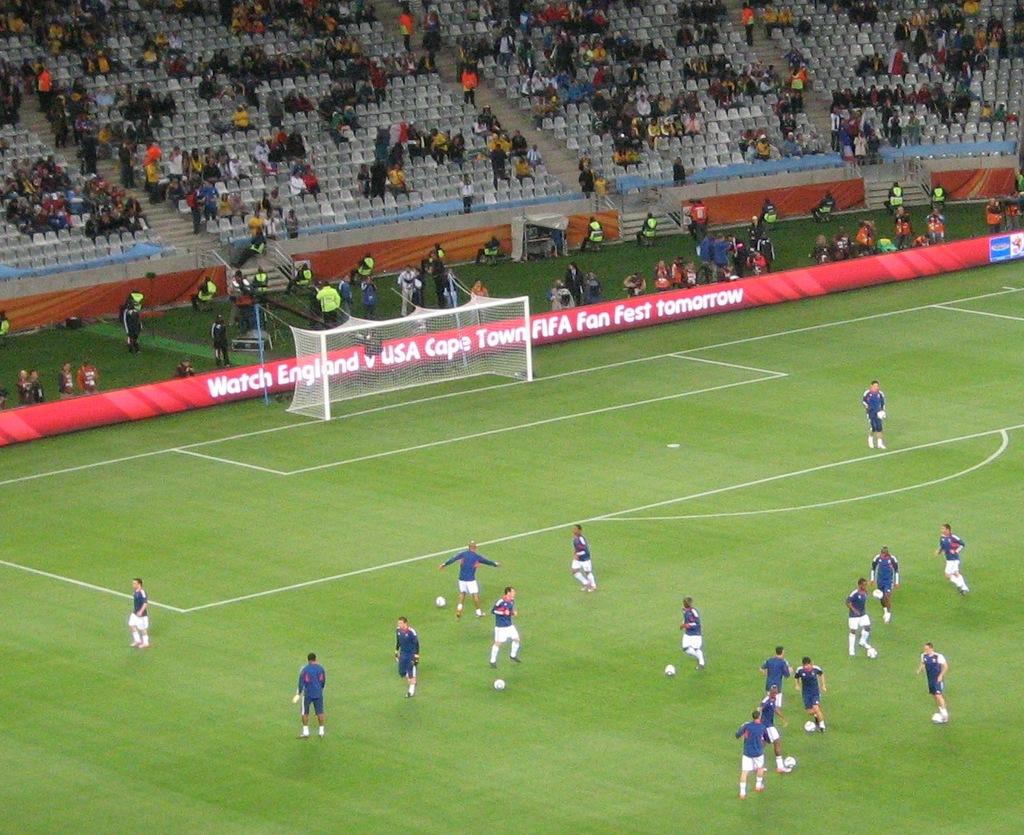What does the advertisement want you to do about the event tomorrow?
Provide a short and direct response. Watch. What event is scheduled for tomorrow?
Provide a short and direct response. England v usa cape town fifa fan fest. 